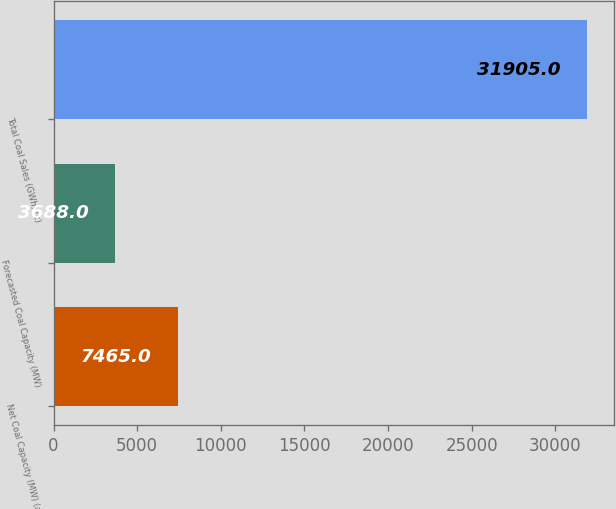<chart> <loc_0><loc_0><loc_500><loc_500><bar_chart><fcel>Net Coal Capacity (MW) (a)<fcel>Forecasted Coal Capacity (MW)<fcel>Total Coal Sales (GWh) (c)<nl><fcel>7465<fcel>3688<fcel>31905<nl></chart> 